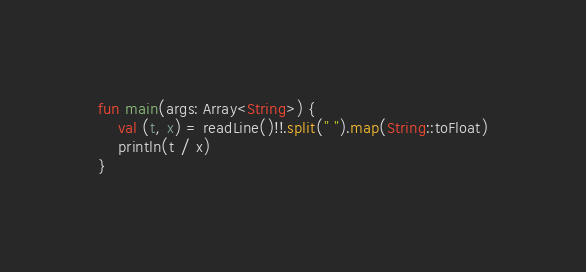Convert code to text. <code><loc_0><loc_0><loc_500><loc_500><_Kotlin_>fun main(args: Array<String>) {
    val (t, x) = readLine()!!.split(" ").map(String::toFloat)
    println(t / x)
}</code> 